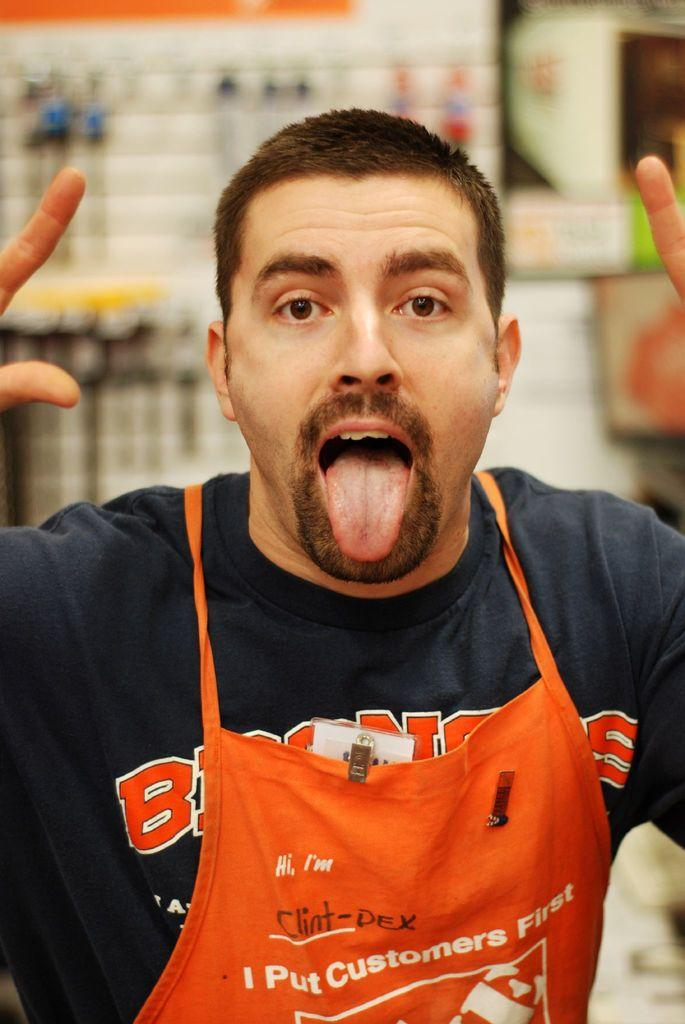Provide a one-sentence caption for the provided image. A Home Depo employee with an apron on that puts customers first. 